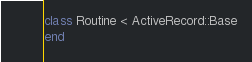Convert code to text. <code><loc_0><loc_0><loc_500><loc_500><_Ruby_>class Routine < ActiveRecord::Base
end
</code> 